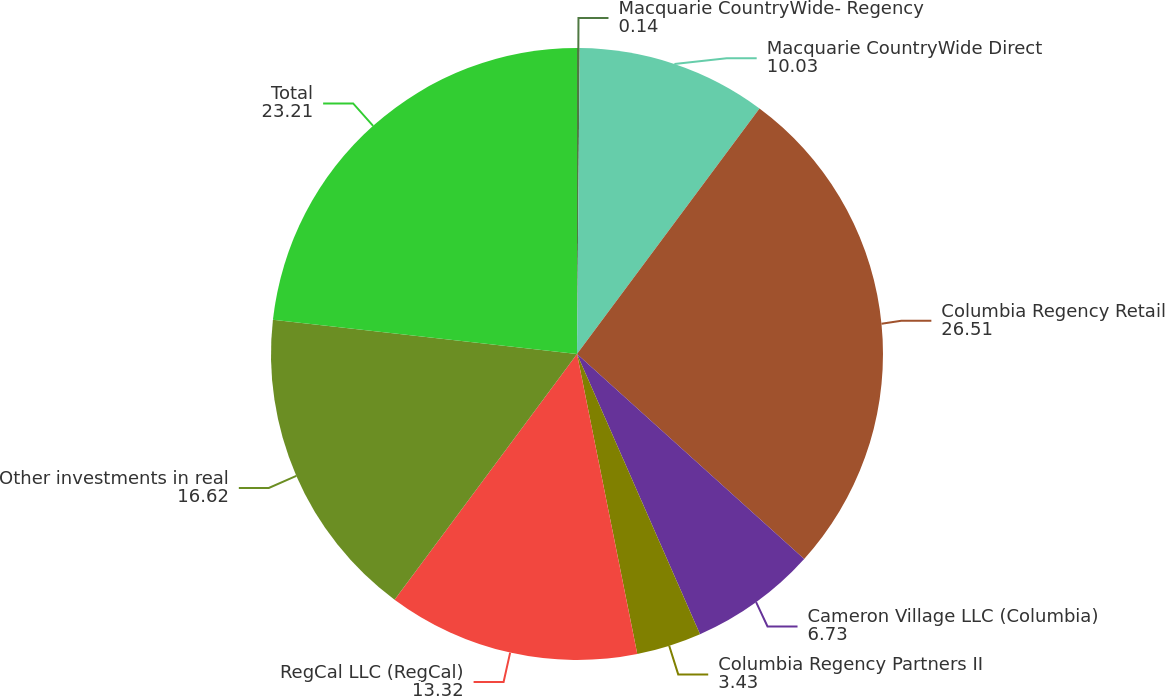Convert chart. <chart><loc_0><loc_0><loc_500><loc_500><pie_chart><fcel>Macquarie CountryWide- Regency<fcel>Macquarie CountryWide Direct<fcel>Columbia Regency Retail<fcel>Cameron Village LLC (Columbia)<fcel>Columbia Regency Partners II<fcel>RegCal LLC (RegCal)<fcel>Other investments in real<fcel>Total<nl><fcel>0.14%<fcel>10.03%<fcel>26.51%<fcel>6.73%<fcel>3.43%<fcel>13.32%<fcel>16.62%<fcel>23.21%<nl></chart> 